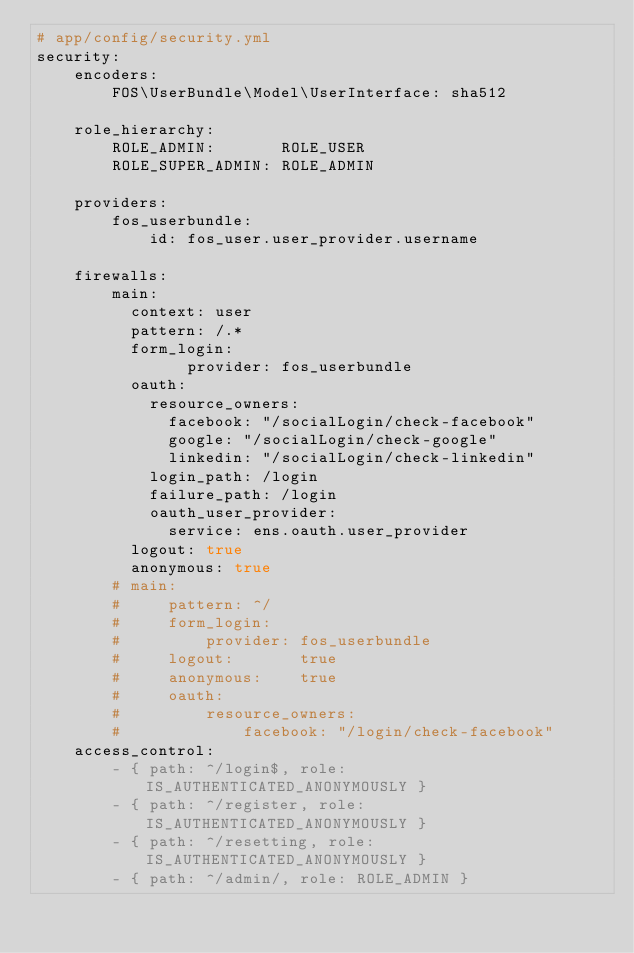Convert code to text. <code><loc_0><loc_0><loc_500><loc_500><_YAML_># app/config/security.yml
security:
    encoders:
        FOS\UserBundle\Model\UserInterface: sha512

    role_hierarchy:
        ROLE_ADMIN:       ROLE_USER
        ROLE_SUPER_ADMIN: ROLE_ADMIN

    providers:
        fos_userbundle:
            id: fos_user.user_provider.username

    firewalls:
        main:
          context: user
          pattern: /.*
          form_login:
                provider: fos_userbundle
          oauth:
            resource_owners:
              facebook: "/socialLogin/check-facebook"
              google: "/socialLogin/check-google"
              linkedin: "/socialLogin/check-linkedin" 
            login_path: /login
            failure_path: /login
            oauth_user_provider:
              service: ens.oauth.user_provider
          logout: true
          anonymous: true
        # main:
        #     pattern: ^/
        #     form_login:
        #         provider: fos_userbundle
        #     logout:       true
        #     anonymous:    true
        #     oauth:
        #         resource_owners:
        #             facebook: "/login/check-facebook"
    access_control:
        - { path: ^/login$, role: IS_AUTHENTICATED_ANONYMOUSLY }
        - { path: ^/register, role: IS_AUTHENTICATED_ANONYMOUSLY }
        - { path: ^/resetting, role: IS_AUTHENTICATED_ANONYMOUSLY }
        - { path: ^/admin/, role: ROLE_ADMIN }
</code> 